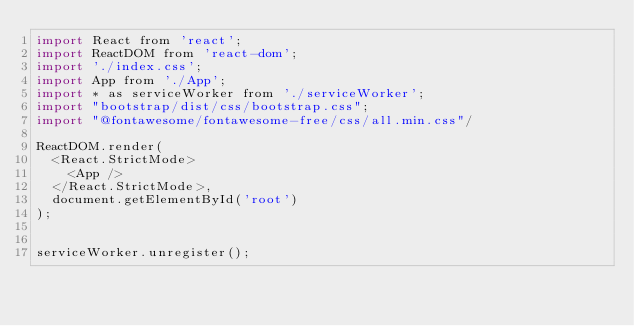<code> <loc_0><loc_0><loc_500><loc_500><_JavaScript_>import React from 'react';
import ReactDOM from 'react-dom';
import './index.css';
import App from './App';
import * as serviceWorker from './serviceWorker';
import "bootstrap/dist/css/bootstrap.css";
import "@fontawesome/fontawesome-free/css/all.min.css"/

ReactDOM.render(
  <React.StrictMode>
    <App />
  </React.StrictMode>,
  document.getElementById('root')
);


serviceWorker.unregister();
</code> 